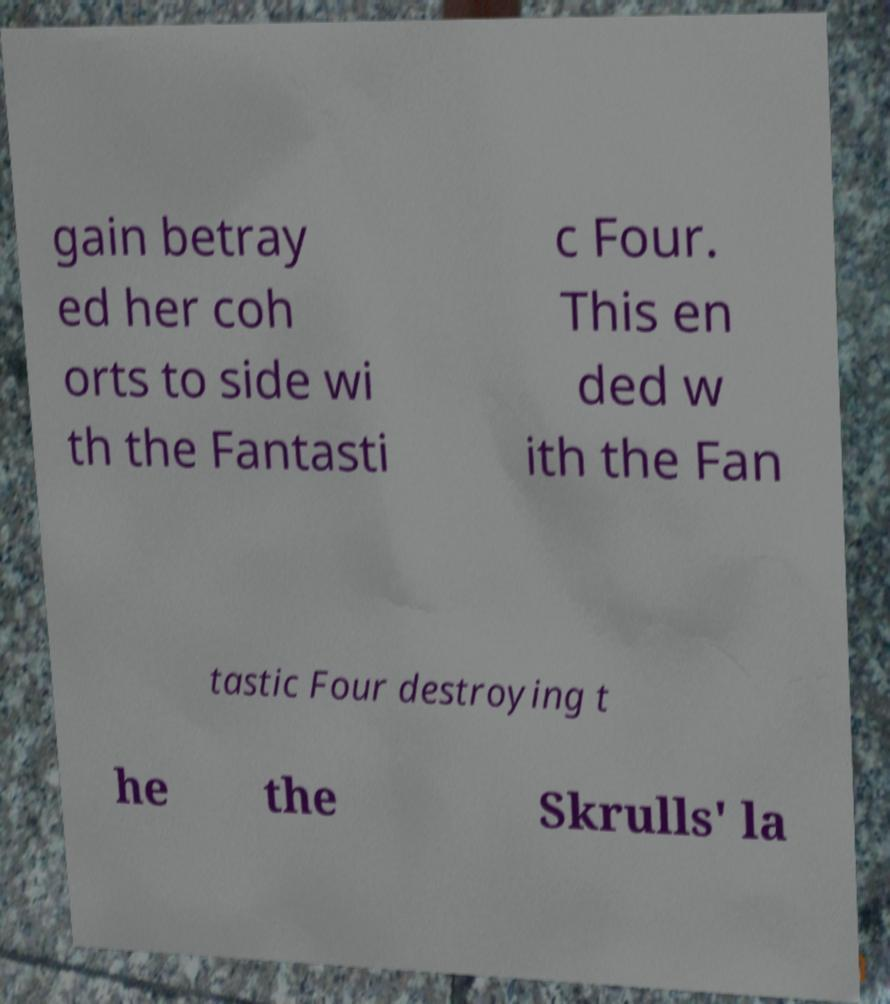Can you read and provide the text displayed in the image?This photo seems to have some interesting text. Can you extract and type it out for me? gain betray ed her coh orts to side wi th the Fantasti c Four. This en ded w ith the Fan tastic Four destroying t he the Skrulls' la 